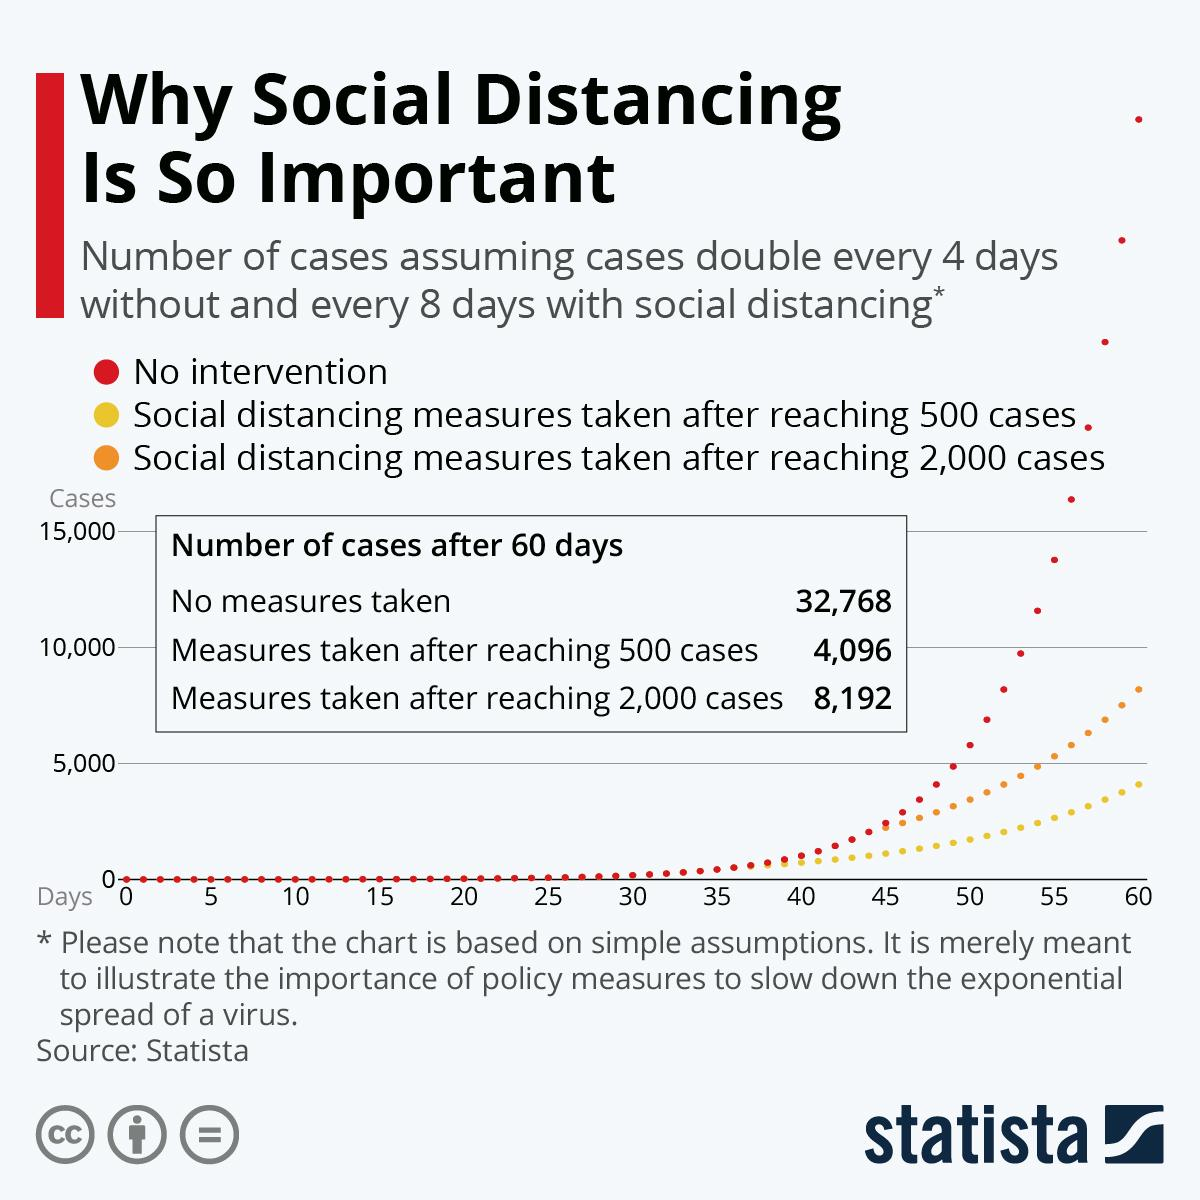Point out several critical features in this image. If measures are taken after 500 and 2000 cases, respectively, the number of cases after 60 days will be different. Specifically, if 4,096 cases are reported after 60 days if measures are taken after 500 cases, but if 8,192 cases are reported after 60 days if measures are taken after 2,000 cases. The parameter that is shown in red on the graph for the "No intervention" scenario is [objective]. The graph displays social distancing measures taken after 500 cases have been reached in yellow color. If there is no intervention, the total number of cases is expected to increase by 15,000 cases. 